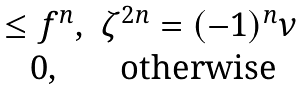<formula> <loc_0><loc_0><loc_500><loc_500>\begin{matrix} \leq f ^ { n } , & \zeta ^ { 2 n } = ( - 1 ) ^ { n } \nu \\ 0 , & \text {otherwise} \end{matrix}</formula> 